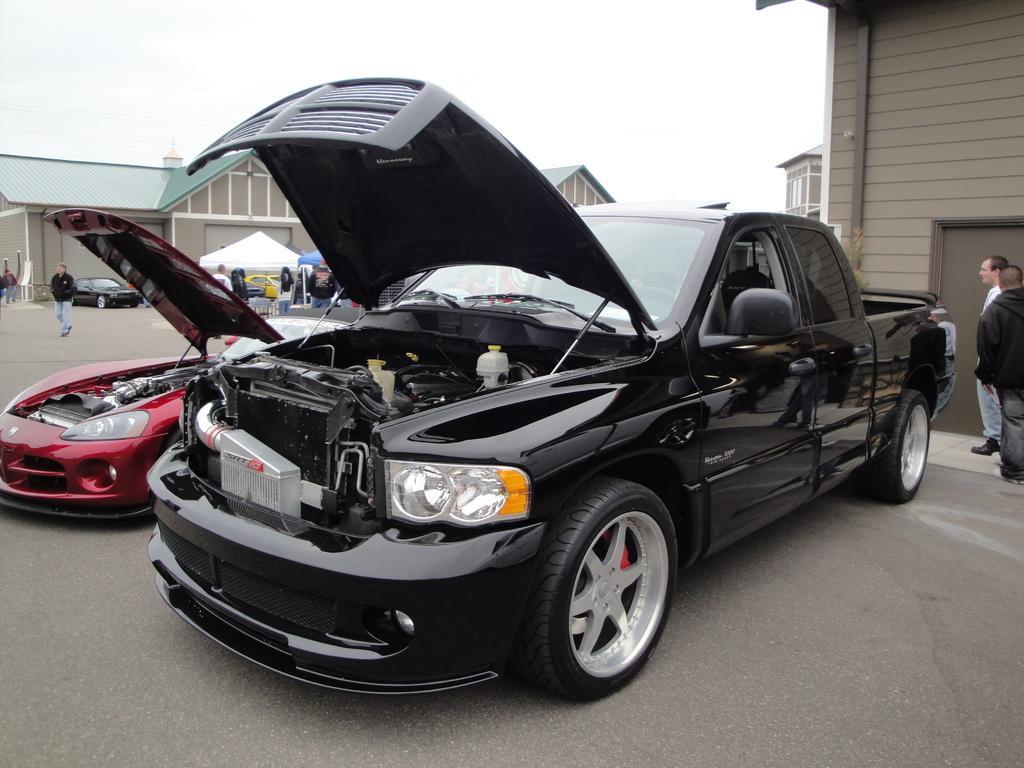Please provide a concise description of this image. There are two cars present in the middle of this image, and there are two persons standing on the right side of this image, and there is a car, tents and some persons standing on the left side of this image. There are some buildings in the background. We can see there is a sky at the top of this image. 